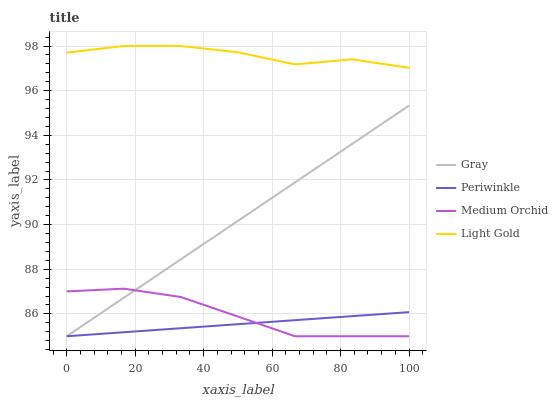Does Medium Orchid have the minimum area under the curve?
Answer yes or no. No. Does Medium Orchid have the maximum area under the curve?
Answer yes or no. No. Is Medium Orchid the smoothest?
Answer yes or no. No. Is Medium Orchid the roughest?
Answer yes or no. No. Does Light Gold have the lowest value?
Answer yes or no. No. Does Medium Orchid have the highest value?
Answer yes or no. No. Is Periwinkle less than Light Gold?
Answer yes or no. Yes. Is Light Gold greater than Gray?
Answer yes or no. Yes. Does Periwinkle intersect Light Gold?
Answer yes or no. No. 